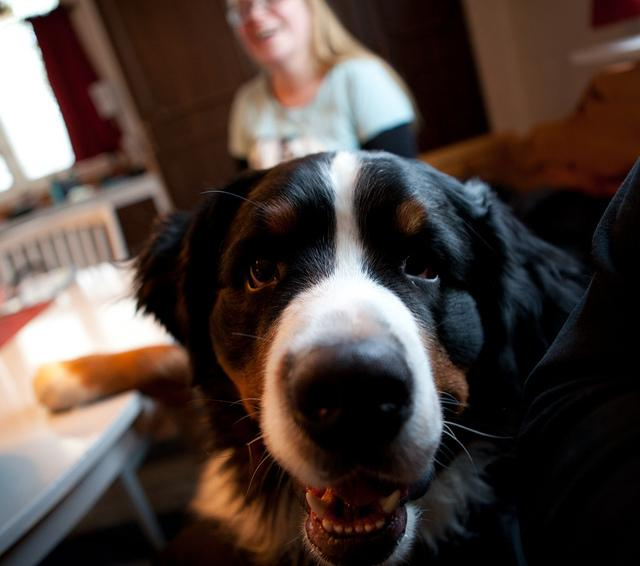What are they looking at? Please explain your reasoning. photographer. The dog is staring into the camera. 